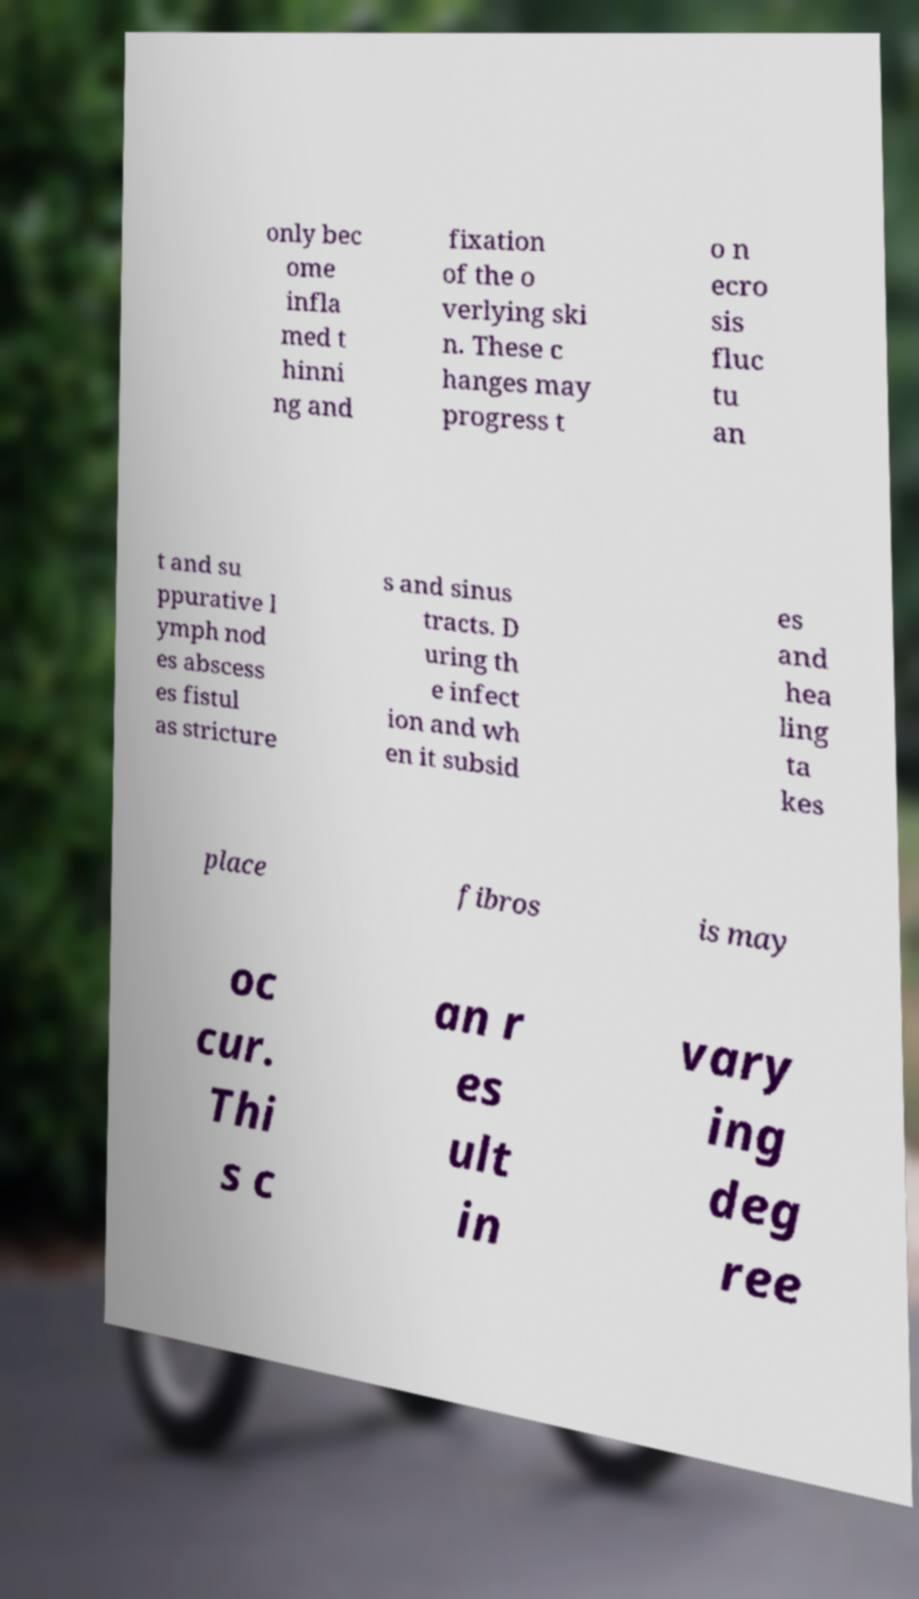Could you assist in decoding the text presented in this image and type it out clearly? only bec ome infla med t hinni ng and fixation of the o verlying ski n. These c hanges may progress t o n ecro sis fluc tu an t and su ppurative l ymph nod es abscess es fistul as stricture s and sinus tracts. D uring th e infect ion and wh en it subsid es and hea ling ta kes place fibros is may oc cur. Thi s c an r es ult in vary ing deg ree 